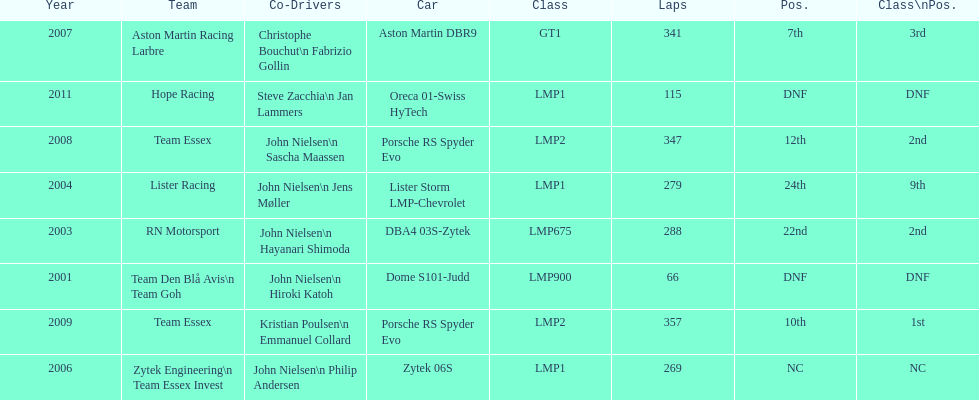How many times was the porsche rs spyder used in competition? 2. 